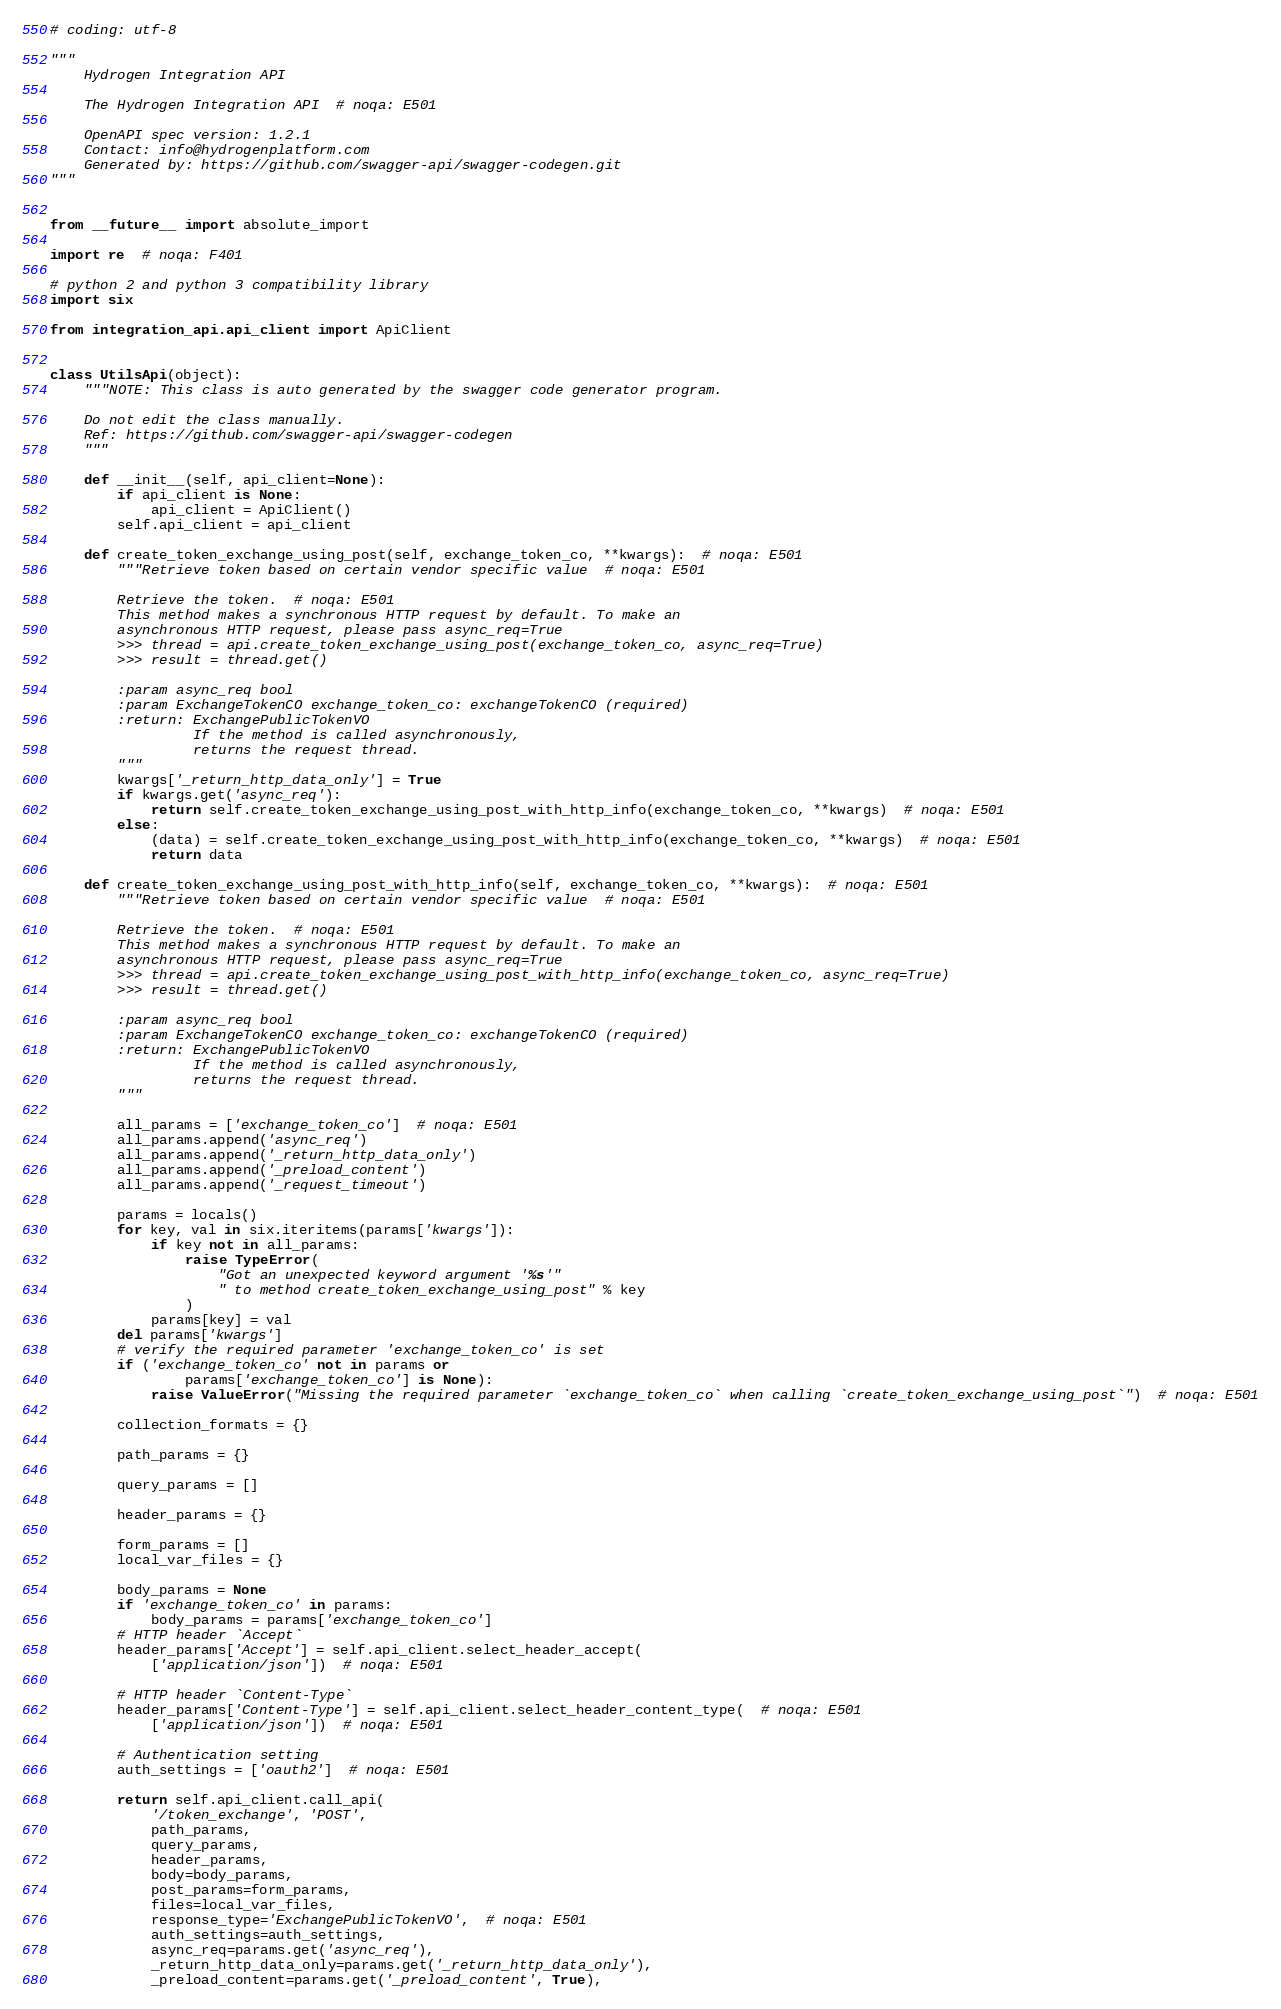<code> <loc_0><loc_0><loc_500><loc_500><_Python_># coding: utf-8

"""
    Hydrogen Integration API

    The Hydrogen Integration API  # noqa: E501

    OpenAPI spec version: 1.2.1
    Contact: info@hydrogenplatform.com
    Generated by: https://github.com/swagger-api/swagger-codegen.git
"""


from __future__ import absolute_import

import re  # noqa: F401

# python 2 and python 3 compatibility library
import six

from integration_api.api_client import ApiClient


class UtilsApi(object):
    """NOTE: This class is auto generated by the swagger code generator program.

    Do not edit the class manually.
    Ref: https://github.com/swagger-api/swagger-codegen
    """

    def __init__(self, api_client=None):
        if api_client is None:
            api_client = ApiClient()
        self.api_client = api_client

    def create_token_exchange_using_post(self, exchange_token_co, **kwargs):  # noqa: E501
        """Retrieve token based on certain vendor specific value  # noqa: E501

        Retrieve the token.  # noqa: E501
        This method makes a synchronous HTTP request by default. To make an
        asynchronous HTTP request, please pass async_req=True
        >>> thread = api.create_token_exchange_using_post(exchange_token_co, async_req=True)
        >>> result = thread.get()

        :param async_req bool
        :param ExchangeTokenCO exchange_token_co: exchangeTokenCO (required)
        :return: ExchangePublicTokenVO
                 If the method is called asynchronously,
                 returns the request thread.
        """
        kwargs['_return_http_data_only'] = True
        if kwargs.get('async_req'):
            return self.create_token_exchange_using_post_with_http_info(exchange_token_co, **kwargs)  # noqa: E501
        else:
            (data) = self.create_token_exchange_using_post_with_http_info(exchange_token_co, **kwargs)  # noqa: E501
            return data

    def create_token_exchange_using_post_with_http_info(self, exchange_token_co, **kwargs):  # noqa: E501
        """Retrieve token based on certain vendor specific value  # noqa: E501

        Retrieve the token.  # noqa: E501
        This method makes a synchronous HTTP request by default. To make an
        asynchronous HTTP request, please pass async_req=True
        >>> thread = api.create_token_exchange_using_post_with_http_info(exchange_token_co, async_req=True)
        >>> result = thread.get()

        :param async_req bool
        :param ExchangeTokenCO exchange_token_co: exchangeTokenCO (required)
        :return: ExchangePublicTokenVO
                 If the method is called asynchronously,
                 returns the request thread.
        """

        all_params = ['exchange_token_co']  # noqa: E501
        all_params.append('async_req')
        all_params.append('_return_http_data_only')
        all_params.append('_preload_content')
        all_params.append('_request_timeout')

        params = locals()
        for key, val in six.iteritems(params['kwargs']):
            if key not in all_params:
                raise TypeError(
                    "Got an unexpected keyword argument '%s'"
                    " to method create_token_exchange_using_post" % key
                )
            params[key] = val
        del params['kwargs']
        # verify the required parameter 'exchange_token_co' is set
        if ('exchange_token_co' not in params or
                params['exchange_token_co'] is None):
            raise ValueError("Missing the required parameter `exchange_token_co` when calling `create_token_exchange_using_post`")  # noqa: E501

        collection_formats = {}

        path_params = {}

        query_params = []

        header_params = {}

        form_params = []
        local_var_files = {}

        body_params = None
        if 'exchange_token_co' in params:
            body_params = params['exchange_token_co']
        # HTTP header `Accept`
        header_params['Accept'] = self.api_client.select_header_accept(
            ['application/json'])  # noqa: E501

        # HTTP header `Content-Type`
        header_params['Content-Type'] = self.api_client.select_header_content_type(  # noqa: E501
            ['application/json'])  # noqa: E501

        # Authentication setting
        auth_settings = ['oauth2']  # noqa: E501

        return self.api_client.call_api(
            '/token_exchange', 'POST',
            path_params,
            query_params,
            header_params,
            body=body_params,
            post_params=form_params,
            files=local_var_files,
            response_type='ExchangePublicTokenVO',  # noqa: E501
            auth_settings=auth_settings,
            async_req=params.get('async_req'),
            _return_http_data_only=params.get('_return_http_data_only'),
            _preload_content=params.get('_preload_content', True),</code> 